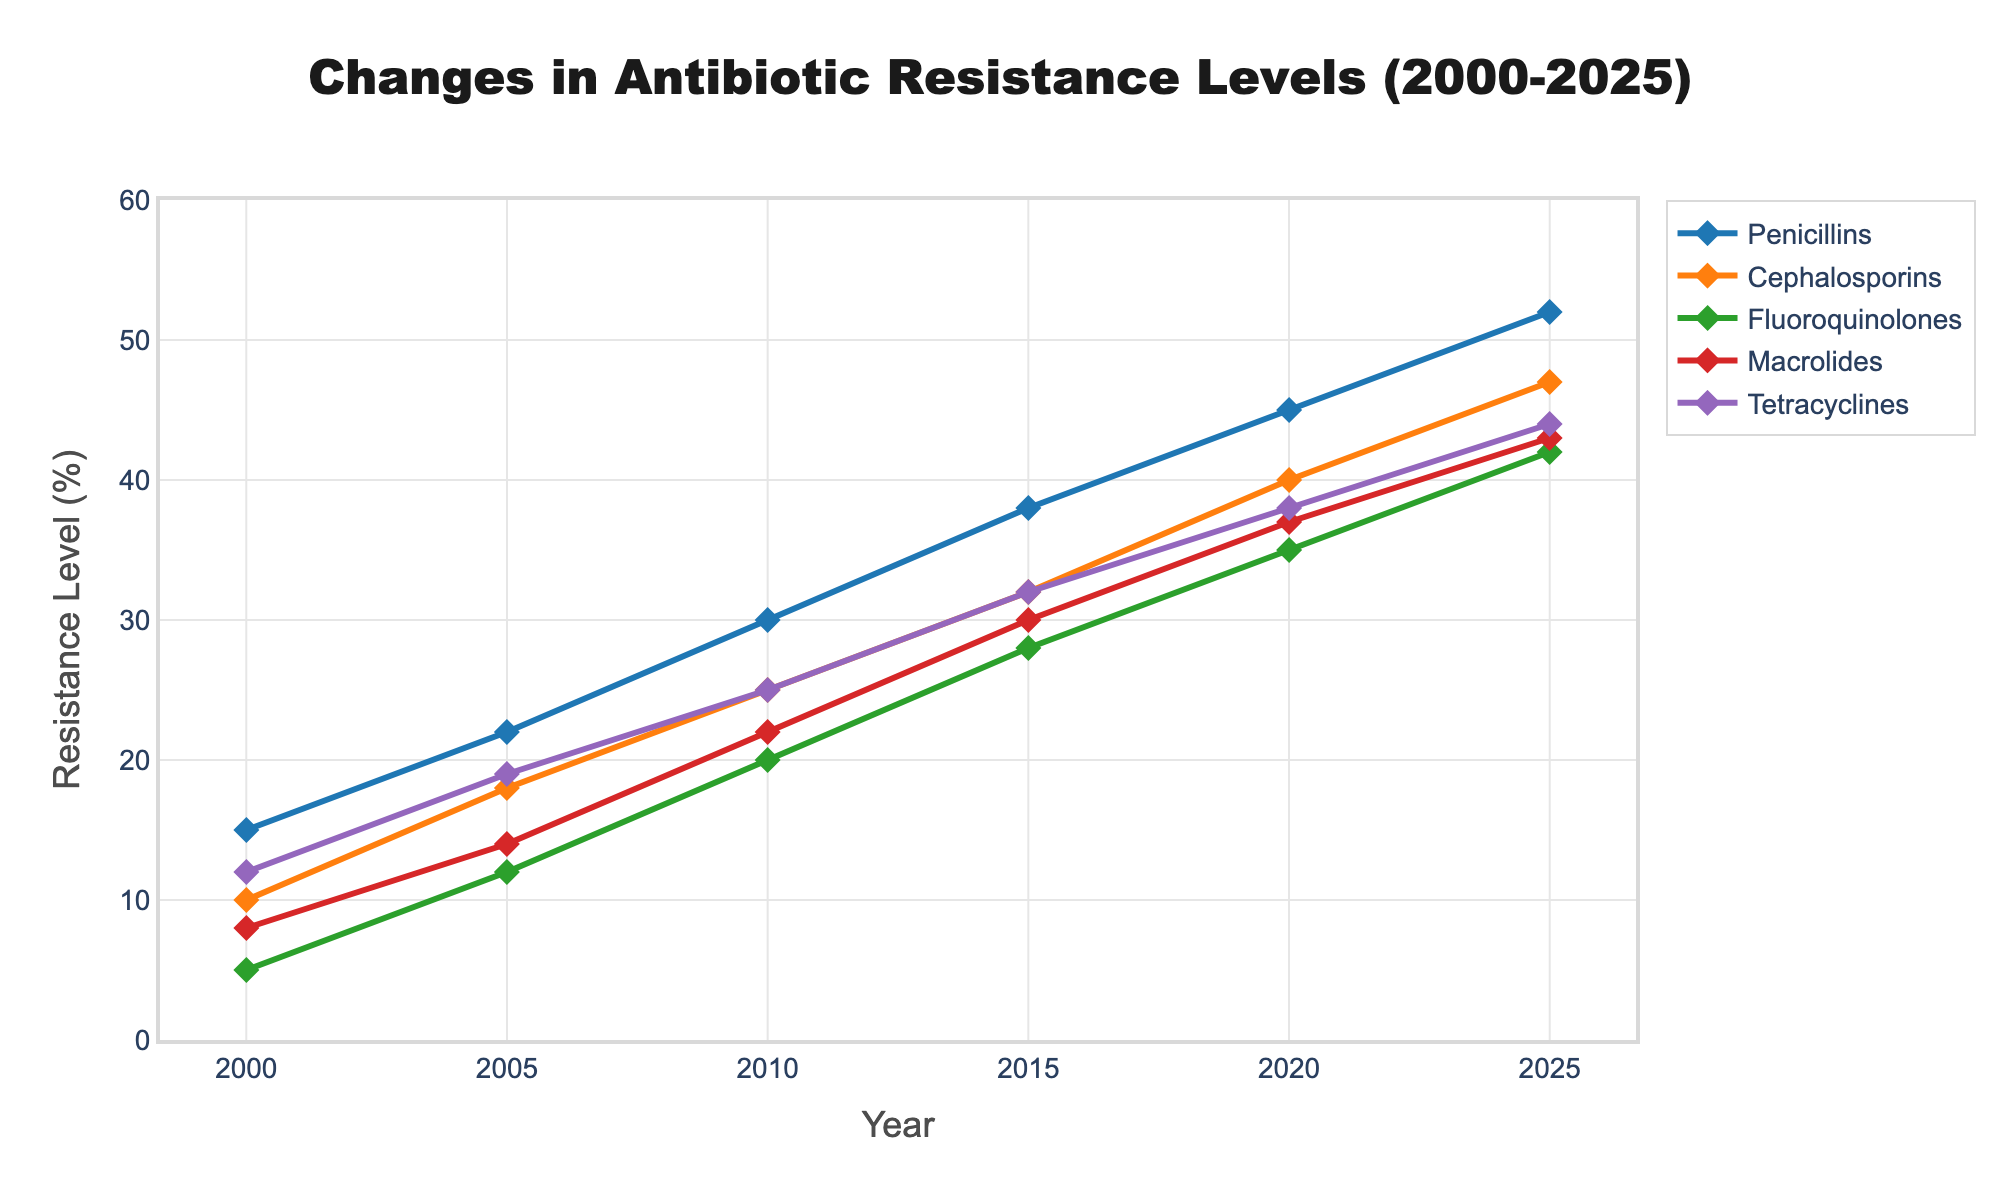What is the difference in antibiotic resistance levels for Cephalosporins between 2000 and 2025? The resistance level in 2000 for Cephalosporins was 10%, and in 2025 it was 47%. The difference can be calculated as 47% - 10% = 37%.
Answer: 37% Which antibiotic class shows the highest resistance level in 2020? In 2020, the antibiotic resistance levels are Penicillins (45%), Cephalosporins (40%), Fluoroquinolones (35%), Macrolides (37%), and Tetracyclines (38%). Penicillins have the highest resistance level at 45%.
Answer: Penicillins What is the average antibiotic resistance level across all classes in 2005? The resistance levels in 2005 are: Penicillins (22%), Cephalosporins (18%), Fluoroquinolones (12%), Macrolides (14%), and Tetracyclines (19%). The average is calculated as (22 + 18 + 12 + 14 + 19) / 5 = 17%.
Answer: 17% How does the resistance level of Macrolides change from 2000 to 2025? In 2000, the resistance level for Macrolides was 8%. By 2025, it increased to 43%. The change can be computed as 43% - 8% = 35%.
Answer: Increased by 35% Between 2010 and 2015, which antibiotic class had the smallest increase in resistance levels? The increases are: Penicillins (38% - 30% = 8%), Cephalosporins (32% - 25% = 7%), Fluoroquinolones (28% - 20% = 8%), Macrolides (30% - 22% = 8%), Tetracyclines (32% - 25% = 7%). Cephalosporins and Tetracyclines both had the smallest increase at 7%.
Answer: Cephalosporins and Tetracyclines Looking at the trends, which antibiotic class is increasing its resistance level the fastest? All antibiotic classes show a steady increase, but Penicillins increase from 15% in 2000 to 52% in 2025. The increase of 37% indicates it has the fastest increase in resistance levels.
Answer: Penicillins What is the combined resistance level of Fluoroquinolones and Macrolides in 2010? Fluoroquinolones have a resistance level of 20%, and Macrolides have 22% in 2010. Combined, they sum up to 20% + 22% = 42%.
Answer: 42% Compare the resistance levels of Tetracyclines and Penicillins in 2025. In 2025, Tetracyclines have a resistance level of 44%, while Penicillins are at 52%. Penicillins are higher than Tetracyclines by 8%.
Answer: Penicillins are 8% higher What is the trend of resistance levels for Fluoroquinolones between 2000 and 2025? Fluoroquinolones show a consistent increase from 5% in 2000 to 42% in 2025.
Answer: Consistent increase In what year does Penicillins reach a resistance level of approximately 30%? Looking at the trend, Penicillins reach around 30% in 2010.
Answer: 2010 